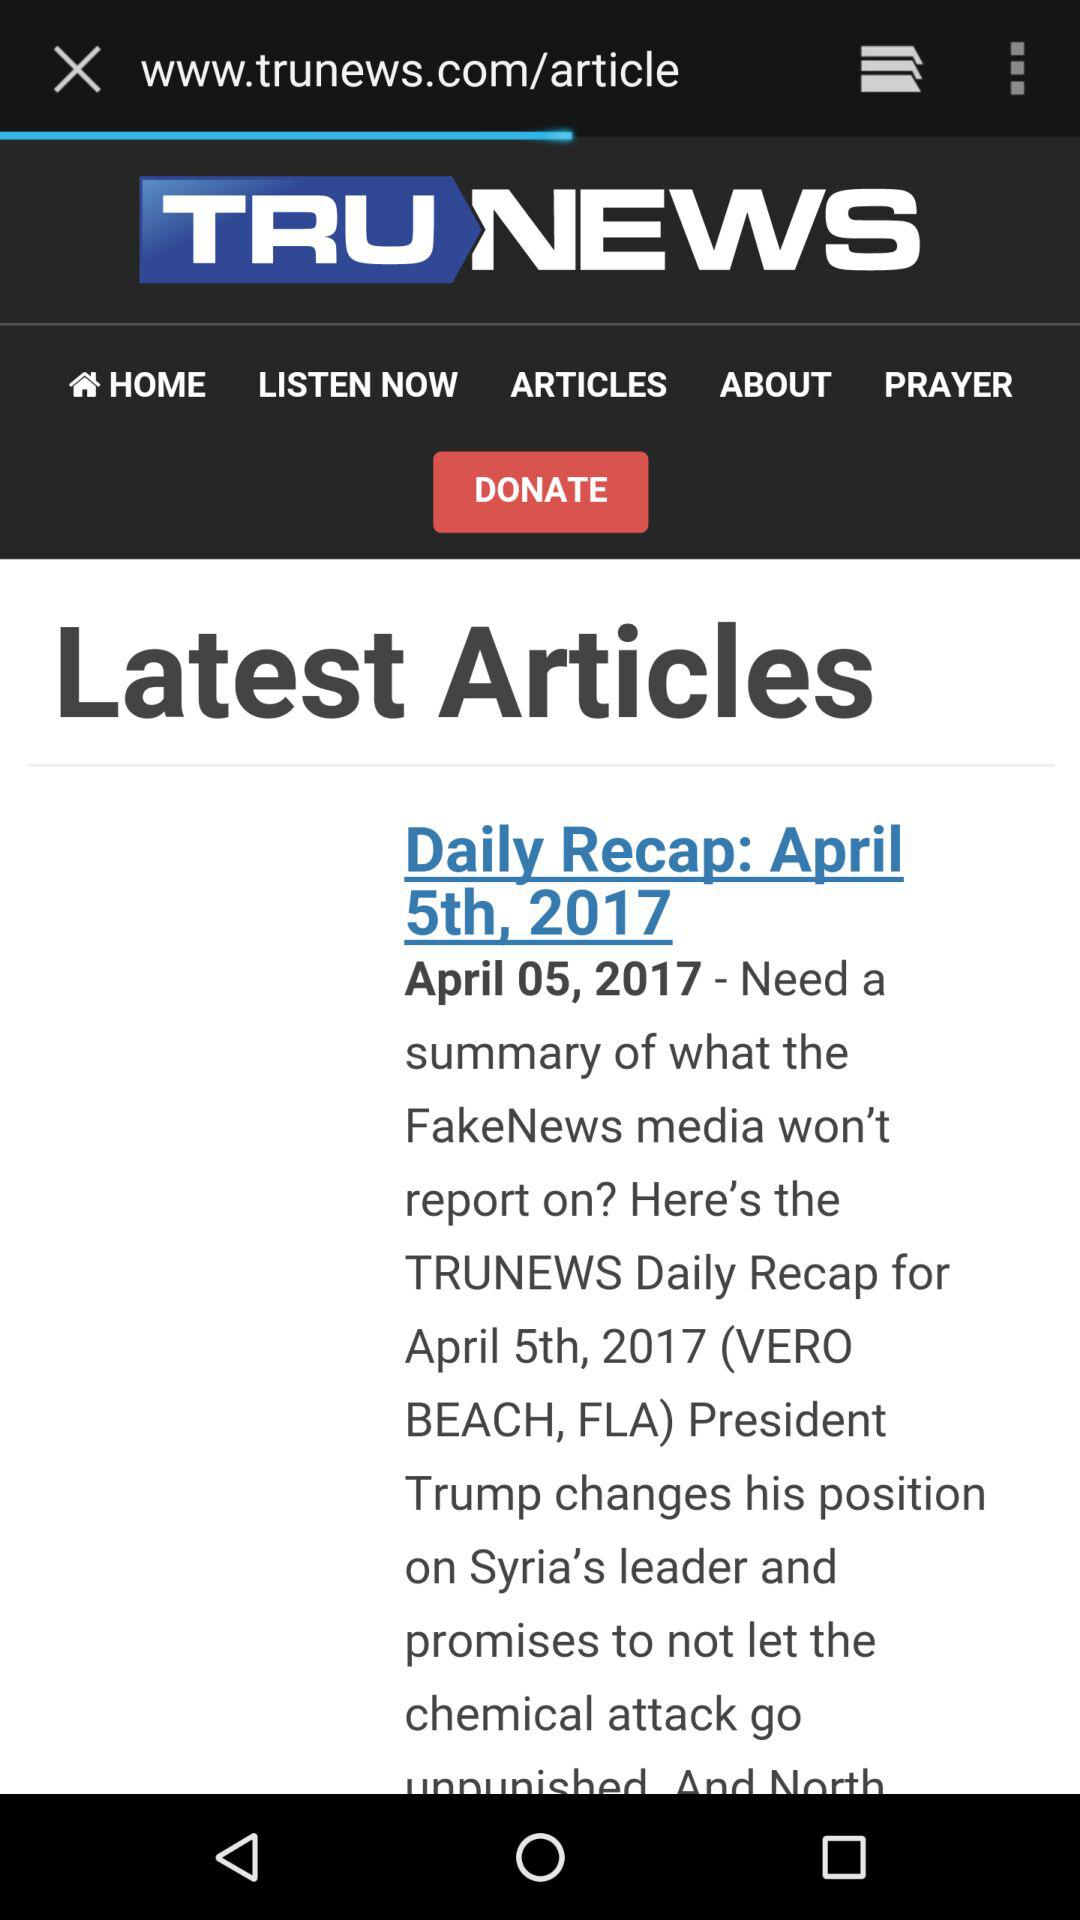At what time was the article published?
When the provided information is insufficient, respond with <no answer>. <no answer> 